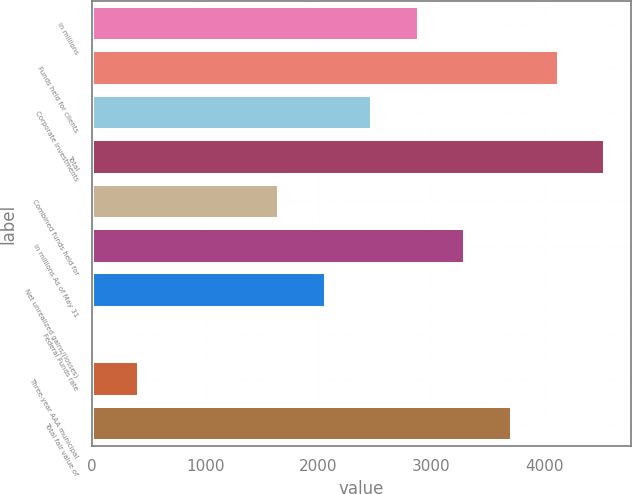Convert chart to OTSL. <chart><loc_0><loc_0><loc_500><loc_500><bar_chart><fcel>in millions<fcel>Funds held for clients<fcel>Corporate investments<fcel>Total<fcel>Combined funds held for<fcel>in millions As of May 31<fcel>Net unrealized gains/(losses)<fcel>Federal Funds rate<fcel>Three-year AAA municipal<fcel>Total fair value of<nl><fcel>2888.52<fcel>4125.6<fcel>2476.16<fcel>4537.96<fcel>1651.44<fcel>3300.88<fcel>2063.8<fcel>2<fcel>414.36<fcel>3713.24<nl></chart> 